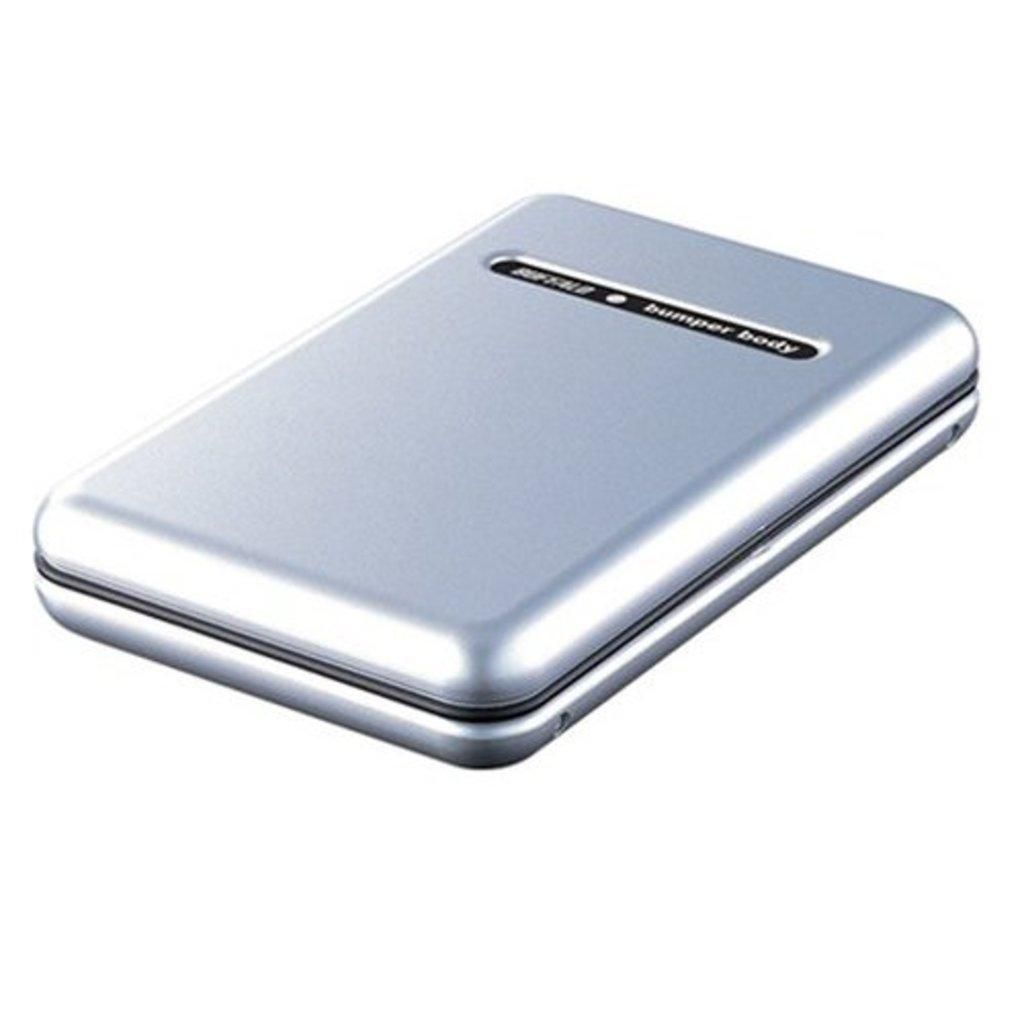<image>
Relay a brief, clear account of the picture shown. A silver case is labeled as bumper body. 